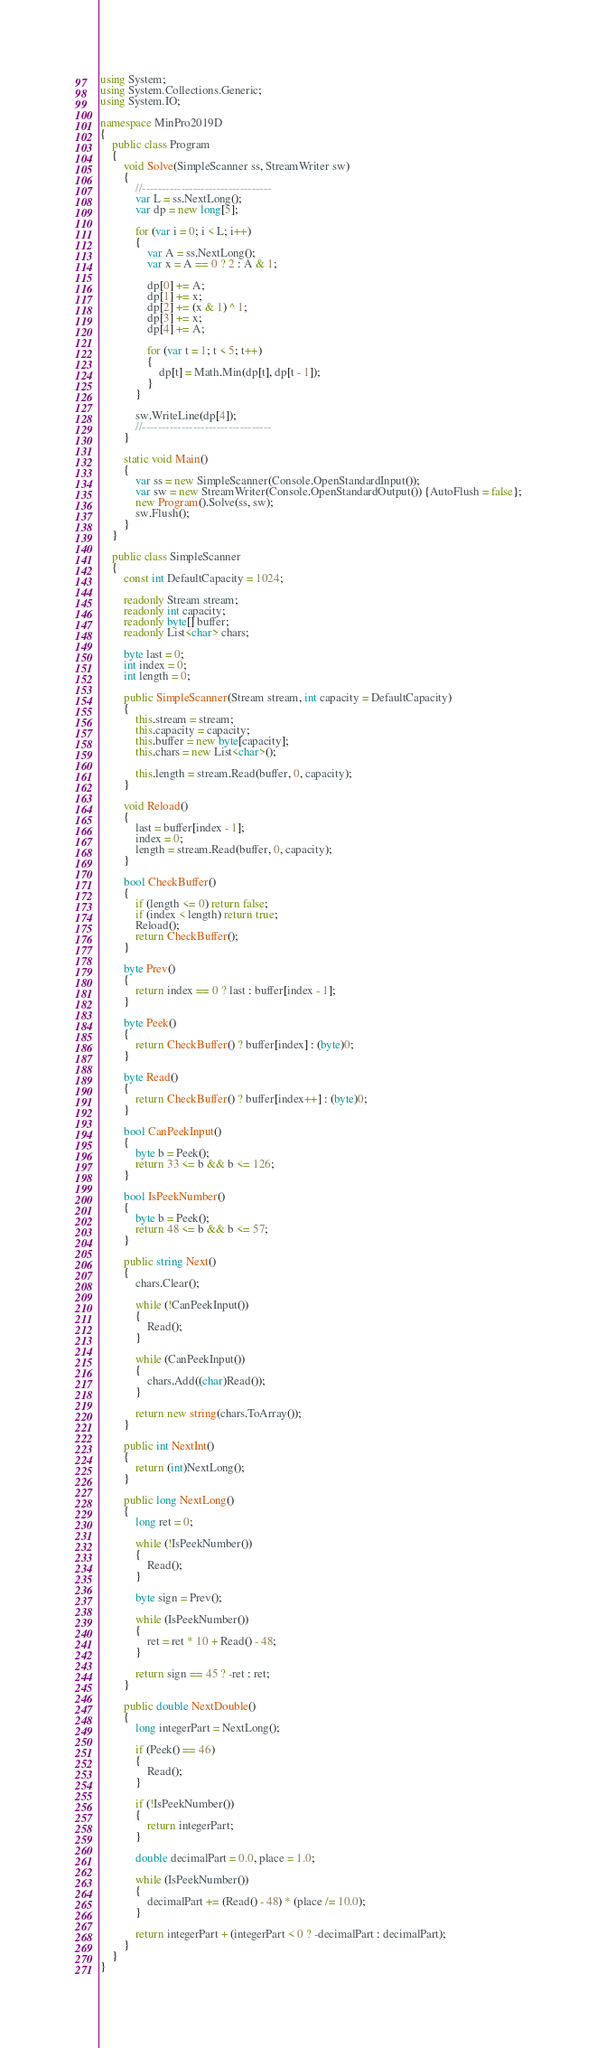<code> <loc_0><loc_0><loc_500><loc_500><_C#_>using System;
using System.Collections.Generic;
using System.IO;

namespace MinPro2019D
{
    public class Program
    {
        void Solve(SimpleScanner ss, StreamWriter sw)
        {
            //---------------------------------
            var L = ss.NextLong();
            var dp = new long[5];

            for (var i = 0; i < L; i++)
            {
                var A = ss.NextLong();
                var x = A == 0 ? 2 : A & 1;

                dp[0] += A;
                dp[1] += x;
                dp[2] += (x & 1) ^ 1;
                dp[3] += x;
                dp[4] += A;

                for (var t = 1; t < 5; t++)
                {
                    dp[t] = Math.Min(dp[t], dp[t - 1]);
                }
            }

            sw.WriteLine(dp[4]);
            //---------------------------------
        }

        static void Main()
        {
            var ss = new SimpleScanner(Console.OpenStandardInput());
            var sw = new StreamWriter(Console.OpenStandardOutput()) {AutoFlush = false};
            new Program().Solve(ss, sw);
            sw.Flush();
        }
    }

    public class SimpleScanner
    {
        const int DefaultCapacity = 1024;

        readonly Stream stream;
        readonly int capacity;
        readonly byte[] buffer;
        readonly List<char> chars;

        byte last = 0;
        int index = 0;
        int length = 0;

        public SimpleScanner(Stream stream, int capacity = DefaultCapacity)
        {
            this.stream = stream;
            this.capacity = capacity;
            this.buffer = new byte[capacity];
            this.chars = new List<char>();

            this.length = stream.Read(buffer, 0, capacity);
        }

        void Reload()
        {
            last = buffer[index - 1];
            index = 0;
            length = stream.Read(buffer, 0, capacity);
        }

        bool CheckBuffer()
        {
            if (length <= 0) return false;
            if (index < length) return true;
            Reload();
            return CheckBuffer();
        }

        byte Prev()
        {
            return index == 0 ? last : buffer[index - 1];
        }

        byte Peek()
        {
            return CheckBuffer() ? buffer[index] : (byte)0;
        }

        byte Read()
        {
            return CheckBuffer() ? buffer[index++] : (byte)0;
        }

        bool CanPeekInput()
        {
            byte b = Peek();
            return 33 <= b && b <= 126;
        }

        bool IsPeekNumber()
        {
            byte b = Peek();
            return 48 <= b && b <= 57;
        }

        public string Next()
        {
            chars.Clear();

            while (!CanPeekInput())
            {
                Read();
            }

            while (CanPeekInput())
            {
                chars.Add((char)Read());
            }

            return new string(chars.ToArray());
        }

        public int NextInt()
        {
            return (int)NextLong();
        }

        public long NextLong()
        {
            long ret = 0;

            while (!IsPeekNumber())
            {
                Read();
            }

            byte sign = Prev();

            while (IsPeekNumber())
            {
                ret = ret * 10 + Read() - 48;
            }

            return sign == 45 ? -ret : ret;
        }

        public double NextDouble()
        {
            long integerPart = NextLong();

            if (Peek() == 46)
            {
                Read();
            }

            if (!IsPeekNumber())
            {
                return integerPart;
            }

            double decimalPart = 0.0, place = 1.0;

            while (IsPeekNumber())
            {
                decimalPart += (Read() - 48) * (place /= 10.0);
            }

            return integerPart + (integerPart < 0 ? -decimalPart : decimalPart);
        }
    }
}
</code> 